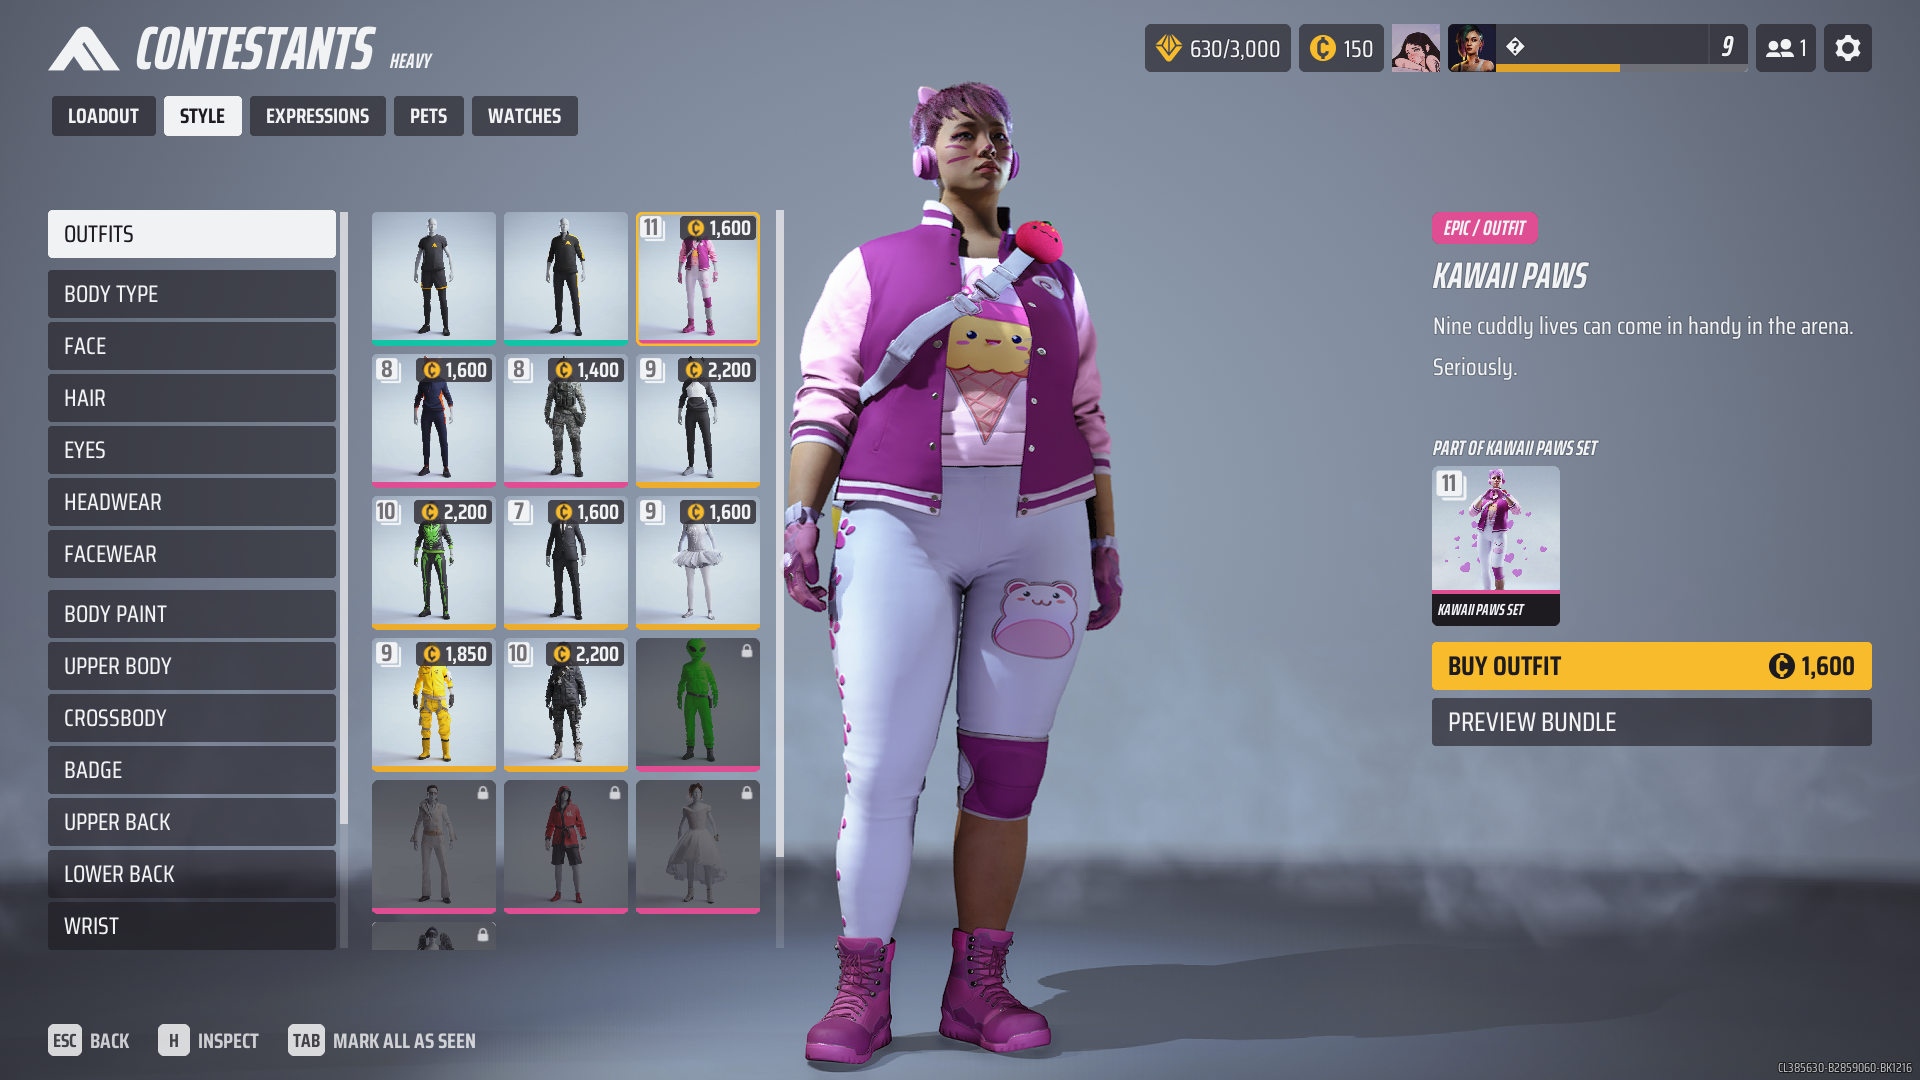delete everything except the person The character is wearing a pink and white outfit with a jacket, pants, and boots. The jacket has a picture of an ice cream cone on it. The character also has a pink and white headset on. 